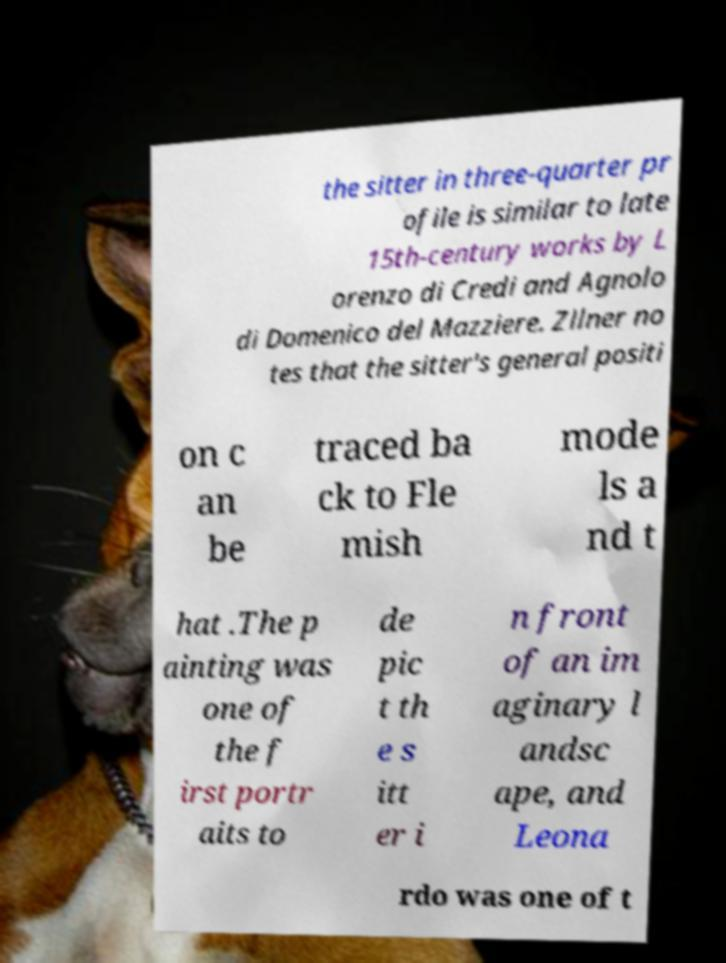Please identify and transcribe the text found in this image. the sitter in three-quarter pr ofile is similar to late 15th-century works by L orenzo di Credi and Agnolo di Domenico del Mazziere. Zllner no tes that the sitter's general positi on c an be traced ba ck to Fle mish mode ls a nd t hat .The p ainting was one of the f irst portr aits to de pic t th e s itt er i n front of an im aginary l andsc ape, and Leona rdo was one of t 